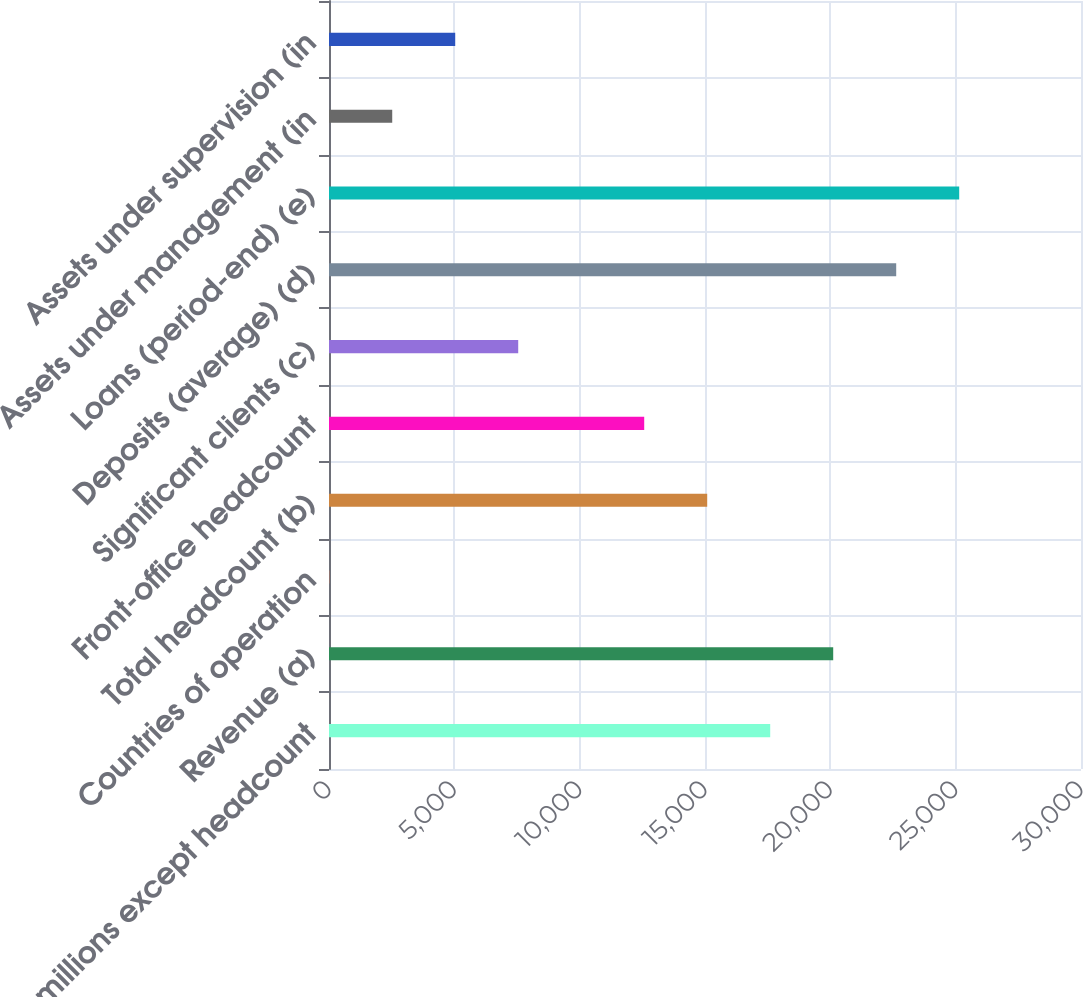Convert chart to OTSL. <chart><loc_0><loc_0><loc_500><loc_500><bar_chart><fcel>(in millions except headcount<fcel>Revenue (a)<fcel>Countries of operation<fcel>Total headcount (b)<fcel>Front-office headcount<fcel>Significant clients (c)<fcel>Deposits (average) (d)<fcel>Loans (period-end) (e)<fcel>Assets under management (in<fcel>Assets under supervision (in<nl><fcel>17601.4<fcel>20114.6<fcel>9<fcel>15088.2<fcel>12575<fcel>7548.6<fcel>22627.8<fcel>25141<fcel>2522.2<fcel>5035.4<nl></chart> 